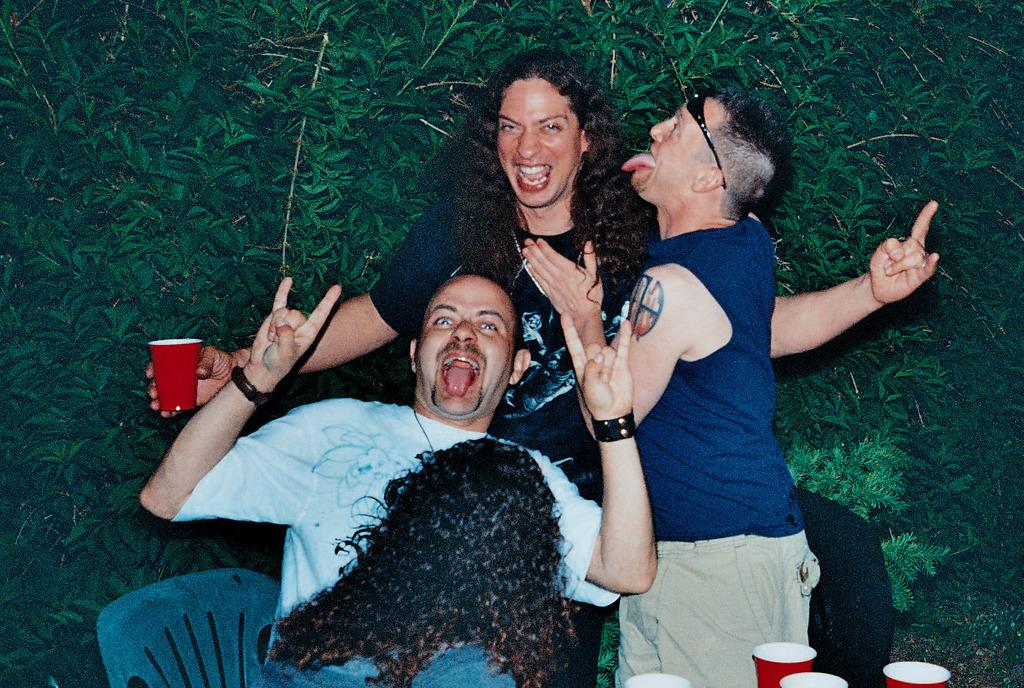What are the people in the image doing? The people in the image are sitting and standing, holding cups, and smiling. What might the people be drinking from the cups? It is not specified what the people are drinking, but they are holding cups. What can be seen in the background of the image? There are trees visible in the background. Where are the glasses located in the image? The glasses are in the bottom right corner of the image. What type of fruit is being used to clean the dirt off the glasses in the image? There is no fruit or dirt present in the image, and the glasses are not being cleaned. 